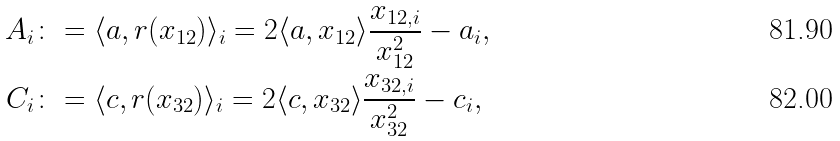<formula> <loc_0><loc_0><loc_500><loc_500>A _ { i } & \colon = \langle a , r ( x _ { 1 2 } ) \rangle _ { i } = 2 \langle a , x _ { 1 2 } \rangle \frac { x _ { 1 2 , i } } { x _ { 1 2 } ^ { 2 } } - a _ { i } , \\ C _ { i } & \colon = \langle c , r ( x _ { 3 2 } ) \rangle _ { i } = 2 \langle c , x _ { 3 2 } \rangle \frac { x _ { 3 2 , i } } { x _ { 3 2 } ^ { 2 } } - c _ { i } ,</formula> 